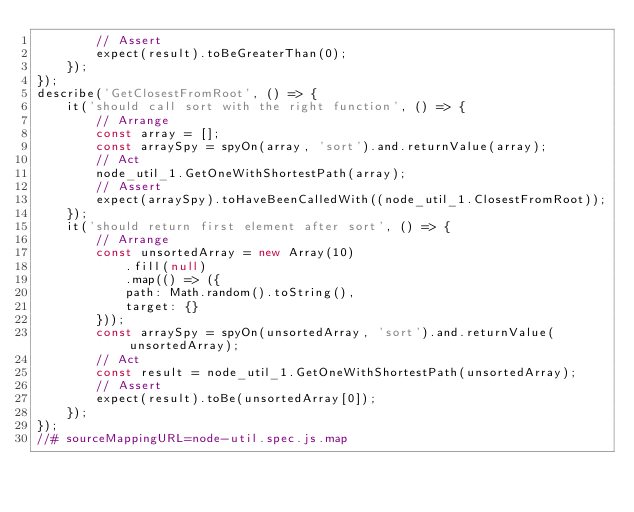Convert code to text. <code><loc_0><loc_0><loc_500><loc_500><_JavaScript_>        // Assert
        expect(result).toBeGreaterThan(0);
    });
});
describe('GetClosestFromRoot', () => {
    it('should call sort with the right function', () => {
        // Arrange
        const array = [];
        const arraySpy = spyOn(array, 'sort').and.returnValue(array);
        // Act
        node_util_1.GetOneWithShortestPath(array);
        // Assert
        expect(arraySpy).toHaveBeenCalledWith((node_util_1.ClosestFromRoot));
    });
    it('should return first element after sort', () => {
        // Arrange
        const unsortedArray = new Array(10)
            .fill(null)
            .map(() => ({
            path: Math.random().toString(),
            target: {}
        }));
        const arraySpy = spyOn(unsortedArray, 'sort').and.returnValue(unsortedArray);
        // Act
        const result = node_util_1.GetOneWithShortestPath(unsortedArray);
        // Assert
        expect(result).toBe(unsortedArray[0]);
    });
});
//# sourceMappingURL=node-util.spec.js.map</code> 